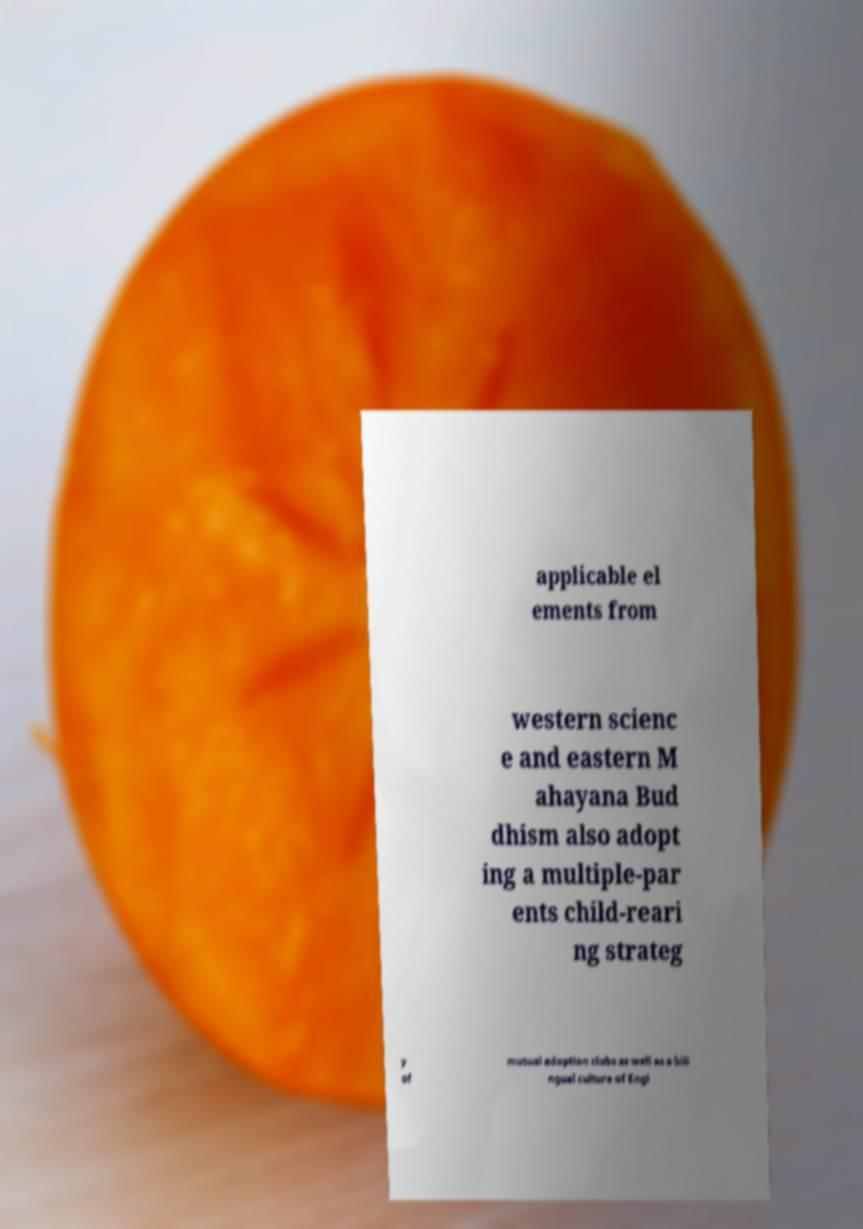Can you read and provide the text displayed in the image?This photo seems to have some interesting text. Can you extract and type it out for me? applicable el ements from western scienc e and eastern M ahayana Bud dhism also adopt ing a multiple-par ents child-reari ng strateg y of mutual adoption clubs as well as a bili ngual culture of Engl 